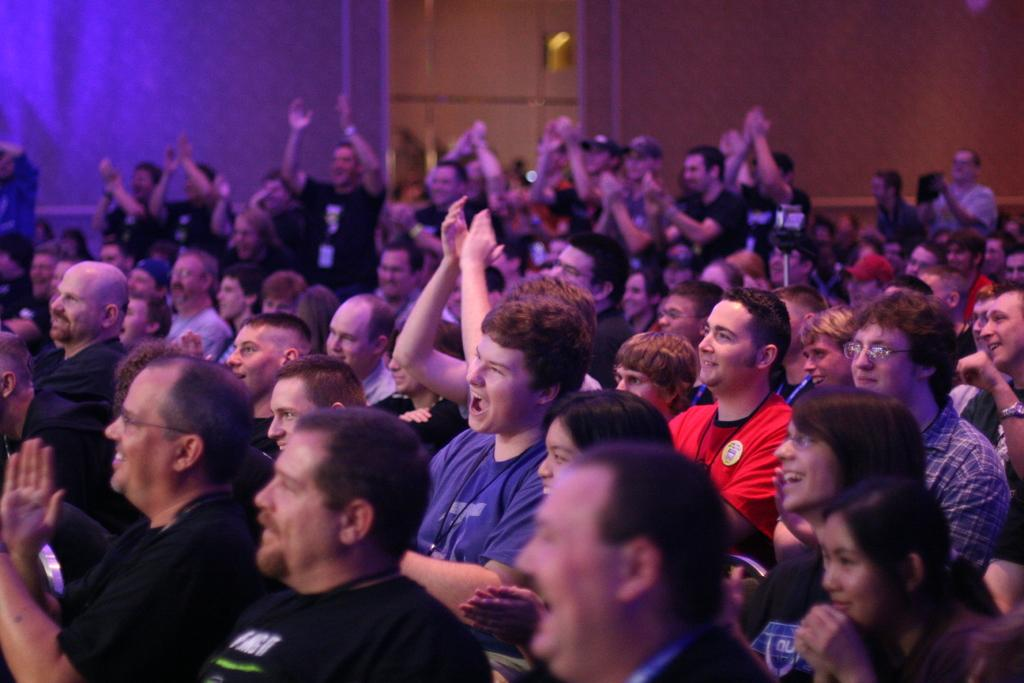What is the main subject of the image? The main subject of the image is a crowd. Can you describe the background of the image? There is a wall visible in the background of the image. What type of lunch is being served to the achievers in the image? There is no mention of achievers or lunch in the image; it only features a crowd and a wall in the background. 